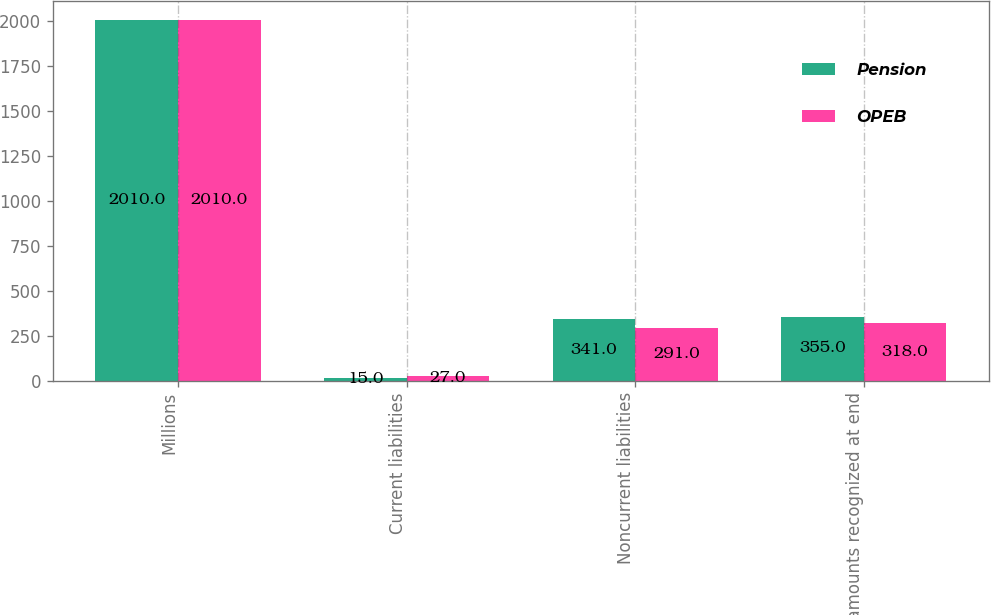Convert chart. <chart><loc_0><loc_0><loc_500><loc_500><stacked_bar_chart><ecel><fcel>Millions<fcel>Current liabilities<fcel>Noncurrent liabilities<fcel>Net amounts recognized at end<nl><fcel>Pension<fcel>2010<fcel>15<fcel>341<fcel>355<nl><fcel>OPEB<fcel>2010<fcel>27<fcel>291<fcel>318<nl></chart> 